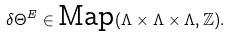Convert formula to latex. <formula><loc_0><loc_0><loc_500><loc_500>\delta \Theta ^ { E } \in \text {Map} ( \Lambda \times \Lambda \times \Lambda , \mathbb { Z } ) .</formula> 